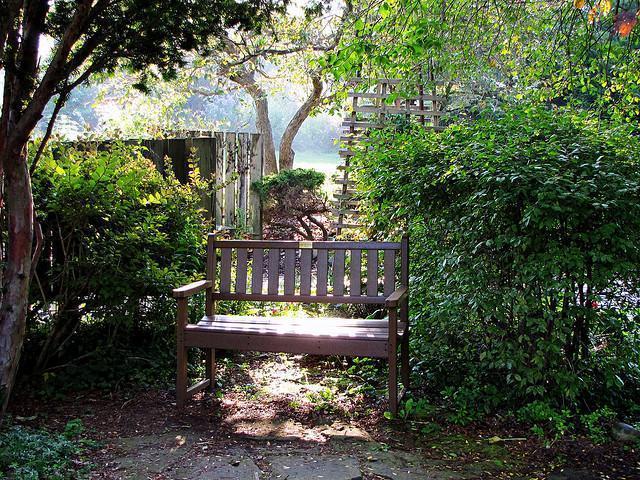How many people are wearing royal blue shorts?
Give a very brief answer. 0. 